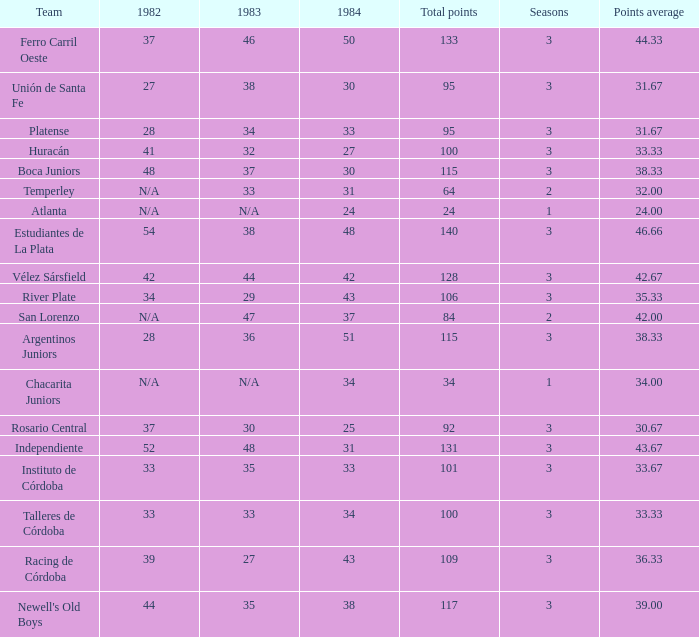For a team with over 100 points and involvement in more than three seasons, what is their total score in 1984? None. 